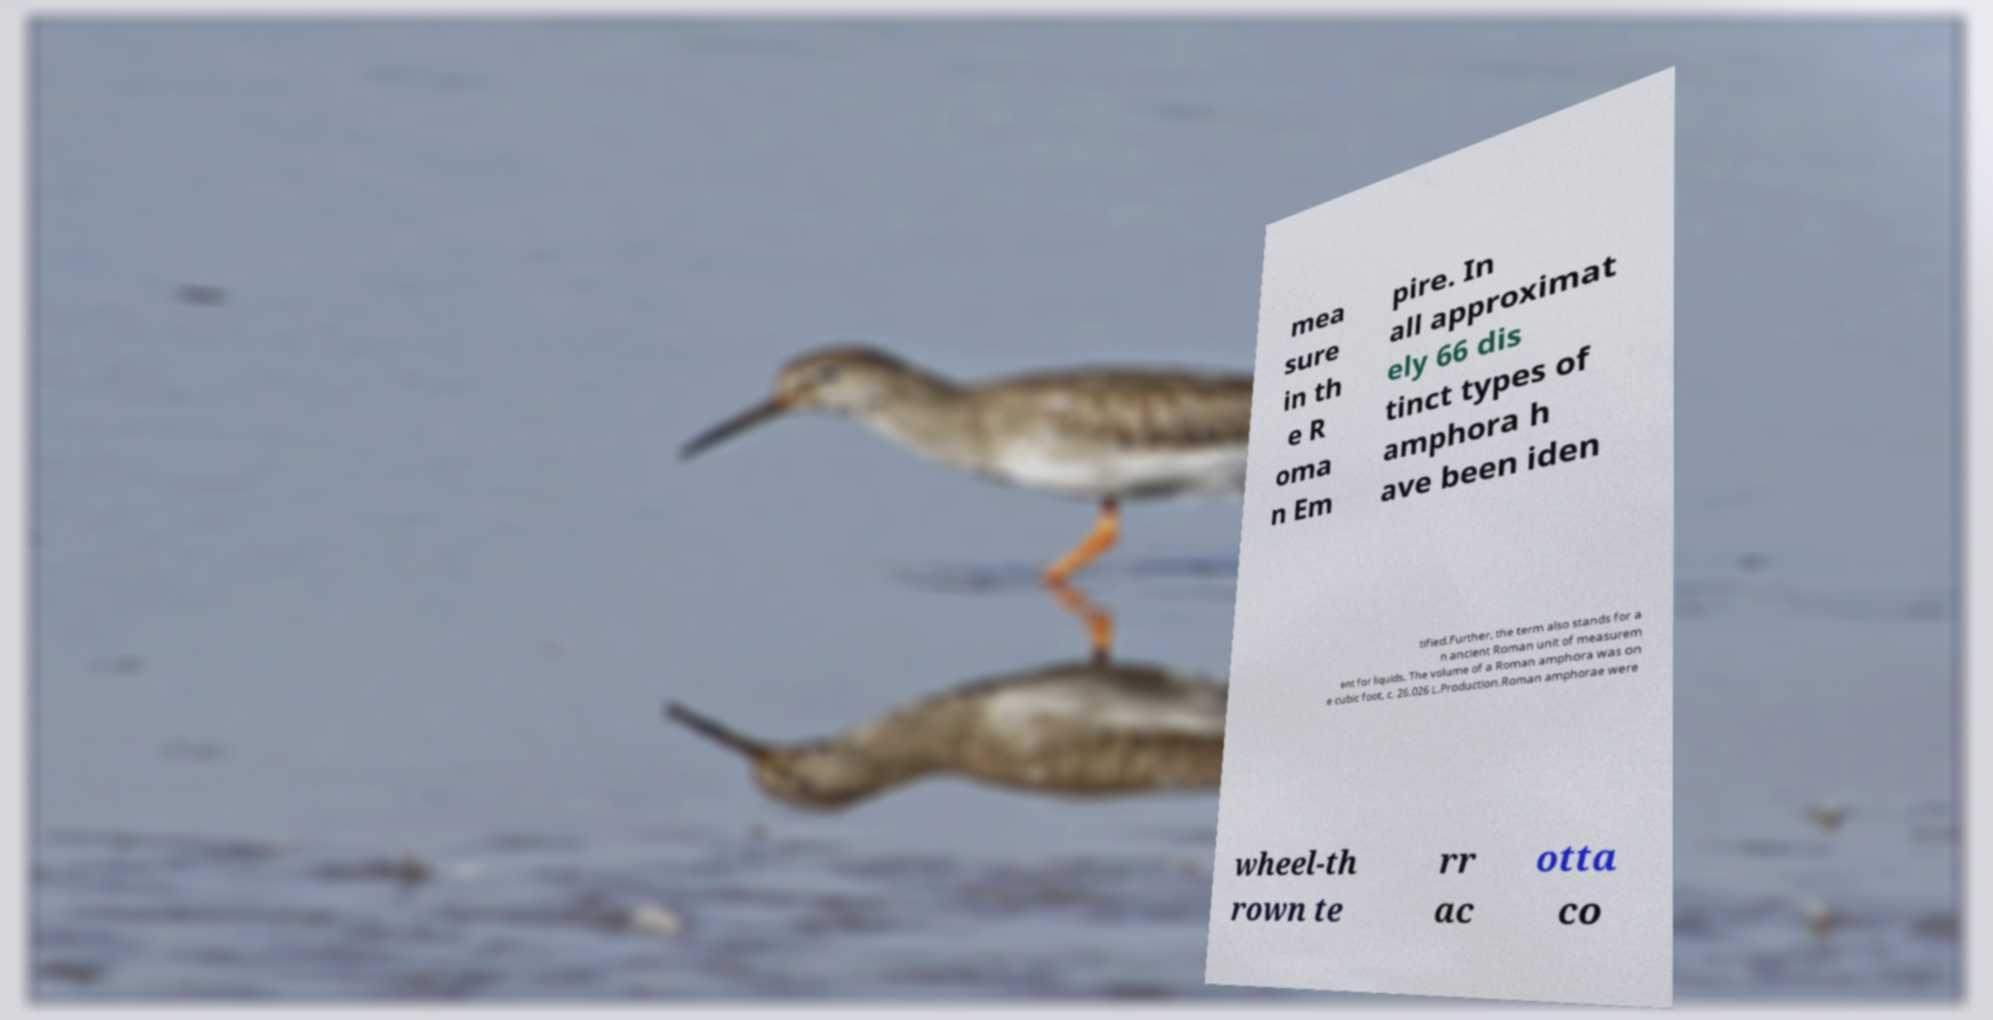There's text embedded in this image that I need extracted. Can you transcribe it verbatim? mea sure in th e R oma n Em pire. In all approximat ely 66 dis tinct types of amphora h ave been iden tified.Further, the term also stands for a n ancient Roman unit of measurem ent for liquids. The volume of a Roman amphora was on e cubic foot, c. 26.026 L.Production.Roman amphorae were wheel-th rown te rr ac otta co 